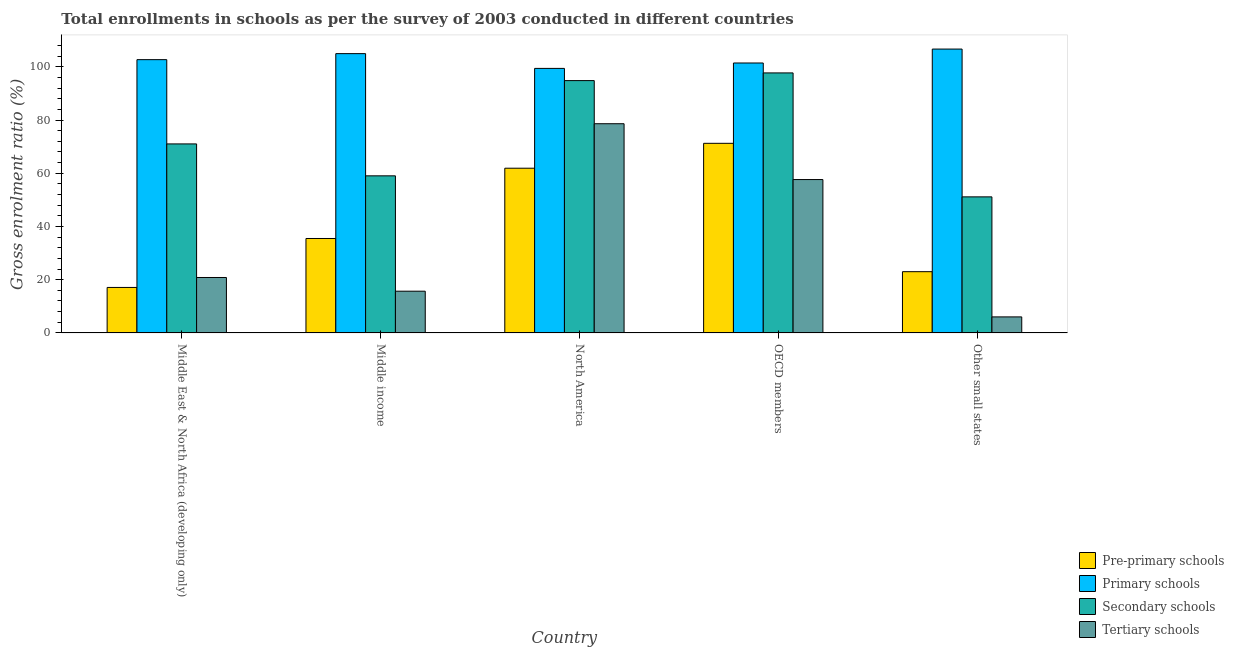How many groups of bars are there?
Ensure brevity in your answer.  5. Are the number of bars on each tick of the X-axis equal?
Offer a very short reply. Yes. What is the label of the 4th group of bars from the left?
Keep it short and to the point. OECD members. What is the gross enrolment ratio in primary schools in Middle East & North Africa (developing only)?
Offer a terse response. 102.67. Across all countries, what is the maximum gross enrolment ratio in tertiary schools?
Ensure brevity in your answer.  78.6. Across all countries, what is the minimum gross enrolment ratio in primary schools?
Provide a succinct answer. 99.39. In which country was the gross enrolment ratio in tertiary schools minimum?
Your answer should be very brief. Other small states. What is the total gross enrolment ratio in secondary schools in the graph?
Give a very brief answer. 373.66. What is the difference between the gross enrolment ratio in secondary schools in Middle East & North Africa (developing only) and that in OECD members?
Provide a succinct answer. -26.67. What is the difference between the gross enrolment ratio in secondary schools in Middle income and the gross enrolment ratio in tertiary schools in Middle East & North Africa (developing only)?
Make the answer very short. 38.19. What is the average gross enrolment ratio in secondary schools per country?
Provide a short and direct response. 74.73. What is the difference between the gross enrolment ratio in primary schools and gross enrolment ratio in secondary schools in North America?
Provide a short and direct response. 4.58. What is the ratio of the gross enrolment ratio in pre-primary schools in Middle income to that in OECD members?
Your response must be concise. 0.5. Is the difference between the gross enrolment ratio in secondary schools in North America and Other small states greater than the difference between the gross enrolment ratio in pre-primary schools in North America and Other small states?
Your answer should be compact. Yes. What is the difference between the highest and the second highest gross enrolment ratio in secondary schools?
Your answer should be very brief. 2.88. What is the difference between the highest and the lowest gross enrolment ratio in pre-primary schools?
Provide a succinct answer. 54.15. In how many countries, is the gross enrolment ratio in tertiary schools greater than the average gross enrolment ratio in tertiary schools taken over all countries?
Keep it short and to the point. 2. What does the 3rd bar from the left in OECD members represents?
Provide a succinct answer. Secondary schools. What does the 1st bar from the right in North America represents?
Offer a very short reply. Tertiary schools. Is it the case that in every country, the sum of the gross enrolment ratio in pre-primary schools and gross enrolment ratio in primary schools is greater than the gross enrolment ratio in secondary schools?
Your answer should be very brief. Yes. How many bars are there?
Your answer should be compact. 20. Are all the bars in the graph horizontal?
Your answer should be very brief. No. How many countries are there in the graph?
Make the answer very short. 5. What is the difference between two consecutive major ticks on the Y-axis?
Offer a terse response. 20. Does the graph contain grids?
Give a very brief answer. No. Where does the legend appear in the graph?
Provide a short and direct response. Bottom right. How are the legend labels stacked?
Your answer should be very brief. Vertical. What is the title of the graph?
Offer a very short reply. Total enrollments in schools as per the survey of 2003 conducted in different countries. Does "UNDP" appear as one of the legend labels in the graph?
Offer a very short reply. No. What is the label or title of the X-axis?
Provide a succinct answer. Country. What is the label or title of the Y-axis?
Keep it short and to the point. Gross enrolment ratio (%). What is the Gross enrolment ratio (%) of Pre-primary schools in Middle East & North Africa (developing only)?
Your answer should be very brief. 17.09. What is the Gross enrolment ratio (%) in Primary schools in Middle East & North Africa (developing only)?
Offer a very short reply. 102.67. What is the Gross enrolment ratio (%) in Secondary schools in Middle East & North Africa (developing only)?
Your response must be concise. 71.02. What is the Gross enrolment ratio (%) in Tertiary schools in Middle East & North Africa (developing only)?
Ensure brevity in your answer.  20.83. What is the Gross enrolment ratio (%) of Pre-primary schools in Middle income?
Offer a terse response. 35.49. What is the Gross enrolment ratio (%) of Primary schools in Middle income?
Offer a very short reply. 104.94. What is the Gross enrolment ratio (%) of Secondary schools in Middle income?
Give a very brief answer. 59.02. What is the Gross enrolment ratio (%) in Tertiary schools in Middle income?
Offer a terse response. 15.69. What is the Gross enrolment ratio (%) of Pre-primary schools in North America?
Provide a short and direct response. 61.89. What is the Gross enrolment ratio (%) of Primary schools in North America?
Give a very brief answer. 99.39. What is the Gross enrolment ratio (%) in Secondary schools in North America?
Make the answer very short. 94.81. What is the Gross enrolment ratio (%) of Tertiary schools in North America?
Ensure brevity in your answer.  78.6. What is the Gross enrolment ratio (%) of Pre-primary schools in OECD members?
Your response must be concise. 71.24. What is the Gross enrolment ratio (%) of Primary schools in OECD members?
Give a very brief answer. 101.42. What is the Gross enrolment ratio (%) in Secondary schools in OECD members?
Ensure brevity in your answer.  97.69. What is the Gross enrolment ratio (%) of Tertiary schools in OECD members?
Make the answer very short. 57.63. What is the Gross enrolment ratio (%) of Pre-primary schools in Other small states?
Provide a succinct answer. 23.01. What is the Gross enrolment ratio (%) in Primary schools in Other small states?
Offer a very short reply. 106.65. What is the Gross enrolment ratio (%) in Secondary schools in Other small states?
Your answer should be compact. 51.12. What is the Gross enrolment ratio (%) of Tertiary schools in Other small states?
Keep it short and to the point. 6.02. Across all countries, what is the maximum Gross enrolment ratio (%) of Pre-primary schools?
Your answer should be very brief. 71.24. Across all countries, what is the maximum Gross enrolment ratio (%) in Primary schools?
Make the answer very short. 106.65. Across all countries, what is the maximum Gross enrolment ratio (%) of Secondary schools?
Provide a succinct answer. 97.69. Across all countries, what is the maximum Gross enrolment ratio (%) of Tertiary schools?
Offer a terse response. 78.6. Across all countries, what is the minimum Gross enrolment ratio (%) of Pre-primary schools?
Offer a terse response. 17.09. Across all countries, what is the minimum Gross enrolment ratio (%) of Primary schools?
Keep it short and to the point. 99.39. Across all countries, what is the minimum Gross enrolment ratio (%) in Secondary schools?
Ensure brevity in your answer.  51.12. Across all countries, what is the minimum Gross enrolment ratio (%) in Tertiary schools?
Make the answer very short. 6.02. What is the total Gross enrolment ratio (%) in Pre-primary schools in the graph?
Your response must be concise. 208.72. What is the total Gross enrolment ratio (%) in Primary schools in the graph?
Your answer should be compact. 515.07. What is the total Gross enrolment ratio (%) in Secondary schools in the graph?
Your answer should be compact. 373.66. What is the total Gross enrolment ratio (%) in Tertiary schools in the graph?
Make the answer very short. 178.77. What is the difference between the Gross enrolment ratio (%) in Pre-primary schools in Middle East & North Africa (developing only) and that in Middle income?
Offer a very short reply. -18.4. What is the difference between the Gross enrolment ratio (%) of Primary schools in Middle East & North Africa (developing only) and that in Middle income?
Your answer should be compact. -2.26. What is the difference between the Gross enrolment ratio (%) of Secondary schools in Middle East & North Africa (developing only) and that in Middle income?
Your answer should be very brief. 11.99. What is the difference between the Gross enrolment ratio (%) of Tertiary schools in Middle East & North Africa (developing only) and that in Middle income?
Make the answer very short. 5.15. What is the difference between the Gross enrolment ratio (%) of Pre-primary schools in Middle East & North Africa (developing only) and that in North America?
Provide a short and direct response. -44.8. What is the difference between the Gross enrolment ratio (%) in Primary schools in Middle East & North Africa (developing only) and that in North America?
Offer a very short reply. 3.28. What is the difference between the Gross enrolment ratio (%) in Secondary schools in Middle East & North Africa (developing only) and that in North America?
Your response must be concise. -23.79. What is the difference between the Gross enrolment ratio (%) in Tertiary schools in Middle East & North Africa (developing only) and that in North America?
Offer a very short reply. -57.77. What is the difference between the Gross enrolment ratio (%) in Pre-primary schools in Middle East & North Africa (developing only) and that in OECD members?
Provide a short and direct response. -54.15. What is the difference between the Gross enrolment ratio (%) in Primary schools in Middle East & North Africa (developing only) and that in OECD members?
Provide a succinct answer. 1.25. What is the difference between the Gross enrolment ratio (%) in Secondary schools in Middle East & North Africa (developing only) and that in OECD members?
Make the answer very short. -26.67. What is the difference between the Gross enrolment ratio (%) in Tertiary schools in Middle East & North Africa (developing only) and that in OECD members?
Offer a very short reply. -36.8. What is the difference between the Gross enrolment ratio (%) of Pre-primary schools in Middle East & North Africa (developing only) and that in Other small states?
Give a very brief answer. -5.92. What is the difference between the Gross enrolment ratio (%) in Primary schools in Middle East & North Africa (developing only) and that in Other small states?
Give a very brief answer. -3.98. What is the difference between the Gross enrolment ratio (%) in Secondary schools in Middle East & North Africa (developing only) and that in Other small states?
Provide a succinct answer. 19.89. What is the difference between the Gross enrolment ratio (%) of Tertiary schools in Middle East & North Africa (developing only) and that in Other small states?
Provide a succinct answer. 14.81. What is the difference between the Gross enrolment ratio (%) in Pre-primary schools in Middle income and that in North America?
Provide a short and direct response. -26.4. What is the difference between the Gross enrolment ratio (%) in Primary schools in Middle income and that in North America?
Provide a succinct answer. 5.55. What is the difference between the Gross enrolment ratio (%) in Secondary schools in Middle income and that in North America?
Your response must be concise. -35.78. What is the difference between the Gross enrolment ratio (%) of Tertiary schools in Middle income and that in North America?
Keep it short and to the point. -62.91. What is the difference between the Gross enrolment ratio (%) in Pre-primary schools in Middle income and that in OECD members?
Provide a succinct answer. -35.76. What is the difference between the Gross enrolment ratio (%) in Primary schools in Middle income and that in OECD members?
Your response must be concise. 3.52. What is the difference between the Gross enrolment ratio (%) of Secondary schools in Middle income and that in OECD members?
Your answer should be very brief. -38.67. What is the difference between the Gross enrolment ratio (%) in Tertiary schools in Middle income and that in OECD members?
Offer a terse response. -41.94. What is the difference between the Gross enrolment ratio (%) in Pre-primary schools in Middle income and that in Other small states?
Offer a very short reply. 12.47. What is the difference between the Gross enrolment ratio (%) in Primary schools in Middle income and that in Other small states?
Your answer should be very brief. -1.71. What is the difference between the Gross enrolment ratio (%) of Secondary schools in Middle income and that in Other small states?
Ensure brevity in your answer.  7.9. What is the difference between the Gross enrolment ratio (%) of Tertiary schools in Middle income and that in Other small states?
Provide a short and direct response. 9.66. What is the difference between the Gross enrolment ratio (%) in Pre-primary schools in North America and that in OECD members?
Make the answer very short. -9.35. What is the difference between the Gross enrolment ratio (%) in Primary schools in North America and that in OECD members?
Ensure brevity in your answer.  -2.03. What is the difference between the Gross enrolment ratio (%) in Secondary schools in North America and that in OECD members?
Your answer should be compact. -2.88. What is the difference between the Gross enrolment ratio (%) of Tertiary schools in North America and that in OECD members?
Offer a very short reply. 20.97. What is the difference between the Gross enrolment ratio (%) in Pre-primary schools in North America and that in Other small states?
Provide a succinct answer. 38.88. What is the difference between the Gross enrolment ratio (%) of Primary schools in North America and that in Other small states?
Provide a short and direct response. -7.26. What is the difference between the Gross enrolment ratio (%) in Secondary schools in North America and that in Other small states?
Your response must be concise. 43.68. What is the difference between the Gross enrolment ratio (%) of Tertiary schools in North America and that in Other small states?
Offer a terse response. 72.58. What is the difference between the Gross enrolment ratio (%) of Pre-primary schools in OECD members and that in Other small states?
Your answer should be very brief. 48.23. What is the difference between the Gross enrolment ratio (%) in Primary schools in OECD members and that in Other small states?
Give a very brief answer. -5.23. What is the difference between the Gross enrolment ratio (%) in Secondary schools in OECD members and that in Other small states?
Offer a very short reply. 46.57. What is the difference between the Gross enrolment ratio (%) of Tertiary schools in OECD members and that in Other small states?
Your response must be concise. 51.6. What is the difference between the Gross enrolment ratio (%) in Pre-primary schools in Middle East & North Africa (developing only) and the Gross enrolment ratio (%) in Primary schools in Middle income?
Keep it short and to the point. -87.85. What is the difference between the Gross enrolment ratio (%) in Pre-primary schools in Middle East & North Africa (developing only) and the Gross enrolment ratio (%) in Secondary schools in Middle income?
Ensure brevity in your answer.  -41.93. What is the difference between the Gross enrolment ratio (%) in Pre-primary schools in Middle East & North Africa (developing only) and the Gross enrolment ratio (%) in Tertiary schools in Middle income?
Offer a terse response. 1.41. What is the difference between the Gross enrolment ratio (%) in Primary schools in Middle East & North Africa (developing only) and the Gross enrolment ratio (%) in Secondary schools in Middle income?
Provide a short and direct response. 43.65. What is the difference between the Gross enrolment ratio (%) of Primary schools in Middle East & North Africa (developing only) and the Gross enrolment ratio (%) of Tertiary schools in Middle income?
Your answer should be very brief. 86.99. What is the difference between the Gross enrolment ratio (%) in Secondary schools in Middle East & North Africa (developing only) and the Gross enrolment ratio (%) in Tertiary schools in Middle income?
Your answer should be compact. 55.33. What is the difference between the Gross enrolment ratio (%) of Pre-primary schools in Middle East & North Africa (developing only) and the Gross enrolment ratio (%) of Primary schools in North America?
Offer a terse response. -82.3. What is the difference between the Gross enrolment ratio (%) of Pre-primary schools in Middle East & North Africa (developing only) and the Gross enrolment ratio (%) of Secondary schools in North America?
Provide a short and direct response. -77.71. What is the difference between the Gross enrolment ratio (%) of Pre-primary schools in Middle East & North Africa (developing only) and the Gross enrolment ratio (%) of Tertiary schools in North America?
Provide a succinct answer. -61.51. What is the difference between the Gross enrolment ratio (%) in Primary schools in Middle East & North Africa (developing only) and the Gross enrolment ratio (%) in Secondary schools in North America?
Offer a very short reply. 7.87. What is the difference between the Gross enrolment ratio (%) in Primary schools in Middle East & North Africa (developing only) and the Gross enrolment ratio (%) in Tertiary schools in North America?
Make the answer very short. 24.07. What is the difference between the Gross enrolment ratio (%) of Secondary schools in Middle East & North Africa (developing only) and the Gross enrolment ratio (%) of Tertiary schools in North America?
Provide a succinct answer. -7.58. What is the difference between the Gross enrolment ratio (%) of Pre-primary schools in Middle East & North Africa (developing only) and the Gross enrolment ratio (%) of Primary schools in OECD members?
Your response must be concise. -84.33. What is the difference between the Gross enrolment ratio (%) in Pre-primary schools in Middle East & North Africa (developing only) and the Gross enrolment ratio (%) in Secondary schools in OECD members?
Your answer should be compact. -80.6. What is the difference between the Gross enrolment ratio (%) in Pre-primary schools in Middle East & North Africa (developing only) and the Gross enrolment ratio (%) in Tertiary schools in OECD members?
Provide a succinct answer. -40.54. What is the difference between the Gross enrolment ratio (%) of Primary schools in Middle East & North Africa (developing only) and the Gross enrolment ratio (%) of Secondary schools in OECD members?
Your response must be concise. 4.98. What is the difference between the Gross enrolment ratio (%) in Primary schools in Middle East & North Africa (developing only) and the Gross enrolment ratio (%) in Tertiary schools in OECD members?
Offer a terse response. 45.05. What is the difference between the Gross enrolment ratio (%) in Secondary schools in Middle East & North Africa (developing only) and the Gross enrolment ratio (%) in Tertiary schools in OECD members?
Your answer should be compact. 13.39. What is the difference between the Gross enrolment ratio (%) of Pre-primary schools in Middle East & North Africa (developing only) and the Gross enrolment ratio (%) of Primary schools in Other small states?
Your answer should be very brief. -89.56. What is the difference between the Gross enrolment ratio (%) in Pre-primary schools in Middle East & North Africa (developing only) and the Gross enrolment ratio (%) in Secondary schools in Other small states?
Provide a succinct answer. -34.03. What is the difference between the Gross enrolment ratio (%) of Pre-primary schools in Middle East & North Africa (developing only) and the Gross enrolment ratio (%) of Tertiary schools in Other small states?
Offer a very short reply. 11.07. What is the difference between the Gross enrolment ratio (%) of Primary schools in Middle East & North Africa (developing only) and the Gross enrolment ratio (%) of Secondary schools in Other small states?
Your answer should be compact. 51.55. What is the difference between the Gross enrolment ratio (%) of Primary schools in Middle East & North Africa (developing only) and the Gross enrolment ratio (%) of Tertiary schools in Other small states?
Give a very brief answer. 96.65. What is the difference between the Gross enrolment ratio (%) in Secondary schools in Middle East & North Africa (developing only) and the Gross enrolment ratio (%) in Tertiary schools in Other small states?
Your answer should be very brief. 64.99. What is the difference between the Gross enrolment ratio (%) in Pre-primary schools in Middle income and the Gross enrolment ratio (%) in Primary schools in North America?
Offer a very short reply. -63.9. What is the difference between the Gross enrolment ratio (%) of Pre-primary schools in Middle income and the Gross enrolment ratio (%) of Secondary schools in North America?
Your answer should be very brief. -59.32. What is the difference between the Gross enrolment ratio (%) of Pre-primary schools in Middle income and the Gross enrolment ratio (%) of Tertiary schools in North America?
Ensure brevity in your answer.  -43.11. What is the difference between the Gross enrolment ratio (%) of Primary schools in Middle income and the Gross enrolment ratio (%) of Secondary schools in North America?
Provide a succinct answer. 10.13. What is the difference between the Gross enrolment ratio (%) of Primary schools in Middle income and the Gross enrolment ratio (%) of Tertiary schools in North America?
Ensure brevity in your answer.  26.34. What is the difference between the Gross enrolment ratio (%) in Secondary schools in Middle income and the Gross enrolment ratio (%) in Tertiary schools in North America?
Provide a short and direct response. -19.58. What is the difference between the Gross enrolment ratio (%) of Pre-primary schools in Middle income and the Gross enrolment ratio (%) of Primary schools in OECD members?
Your answer should be compact. -65.94. What is the difference between the Gross enrolment ratio (%) of Pre-primary schools in Middle income and the Gross enrolment ratio (%) of Secondary schools in OECD members?
Your answer should be compact. -62.2. What is the difference between the Gross enrolment ratio (%) in Pre-primary schools in Middle income and the Gross enrolment ratio (%) in Tertiary schools in OECD members?
Ensure brevity in your answer.  -22.14. What is the difference between the Gross enrolment ratio (%) of Primary schools in Middle income and the Gross enrolment ratio (%) of Secondary schools in OECD members?
Your answer should be very brief. 7.25. What is the difference between the Gross enrolment ratio (%) of Primary schools in Middle income and the Gross enrolment ratio (%) of Tertiary schools in OECD members?
Provide a succinct answer. 47.31. What is the difference between the Gross enrolment ratio (%) of Secondary schools in Middle income and the Gross enrolment ratio (%) of Tertiary schools in OECD members?
Your answer should be compact. 1.39. What is the difference between the Gross enrolment ratio (%) in Pre-primary schools in Middle income and the Gross enrolment ratio (%) in Primary schools in Other small states?
Make the answer very short. -71.16. What is the difference between the Gross enrolment ratio (%) in Pre-primary schools in Middle income and the Gross enrolment ratio (%) in Secondary schools in Other small states?
Make the answer very short. -15.64. What is the difference between the Gross enrolment ratio (%) in Pre-primary schools in Middle income and the Gross enrolment ratio (%) in Tertiary schools in Other small states?
Make the answer very short. 29.46. What is the difference between the Gross enrolment ratio (%) of Primary schools in Middle income and the Gross enrolment ratio (%) of Secondary schools in Other small states?
Give a very brief answer. 53.81. What is the difference between the Gross enrolment ratio (%) of Primary schools in Middle income and the Gross enrolment ratio (%) of Tertiary schools in Other small states?
Give a very brief answer. 98.91. What is the difference between the Gross enrolment ratio (%) in Secondary schools in Middle income and the Gross enrolment ratio (%) in Tertiary schools in Other small states?
Ensure brevity in your answer.  53. What is the difference between the Gross enrolment ratio (%) of Pre-primary schools in North America and the Gross enrolment ratio (%) of Primary schools in OECD members?
Ensure brevity in your answer.  -39.53. What is the difference between the Gross enrolment ratio (%) of Pre-primary schools in North America and the Gross enrolment ratio (%) of Secondary schools in OECD members?
Ensure brevity in your answer.  -35.8. What is the difference between the Gross enrolment ratio (%) of Pre-primary schools in North America and the Gross enrolment ratio (%) of Tertiary schools in OECD members?
Offer a terse response. 4.26. What is the difference between the Gross enrolment ratio (%) in Primary schools in North America and the Gross enrolment ratio (%) in Secondary schools in OECD members?
Your response must be concise. 1.7. What is the difference between the Gross enrolment ratio (%) in Primary schools in North America and the Gross enrolment ratio (%) in Tertiary schools in OECD members?
Offer a very short reply. 41.76. What is the difference between the Gross enrolment ratio (%) in Secondary schools in North America and the Gross enrolment ratio (%) in Tertiary schools in OECD members?
Keep it short and to the point. 37.18. What is the difference between the Gross enrolment ratio (%) of Pre-primary schools in North America and the Gross enrolment ratio (%) of Primary schools in Other small states?
Keep it short and to the point. -44.76. What is the difference between the Gross enrolment ratio (%) in Pre-primary schools in North America and the Gross enrolment ratio (%) in Secondary schools in Other small states?
Offer a terse response. 10.77. What is the difference between the Gross enrolment ratio (%) in Pre-primary schools in North America and the Gross enrolment ratio (%) in Tertiary schools in Other small states?
Your response must be concise. 55.86. What is the difference between the Gross enrolment ratio (%) in Primary schools in North America and the Gross enrolment ratio (%) in Secondary schools in Other small states?
Keep it short and to the point. 48.27. What is the difference between the Gross enrolment ratio (%) of Primary schools in North America and the Gross enrolment ratio (%) of Tertiary schools in Other small states?
Provide a short and direct response. 93.36. What is the difference between the Gross enrolment ratio (%) in Secondary schools in North America and the Gross enrolment ratio (%) in Tertiary schools in Other small states?
Your response must be concise. 88.78. What is the difference between the Gross enrolment ratio (%) in Pre-primary schools in OECD members and the Gross enrolment ratio (%) in Primary schools in Other small states?
Provide a short and direct response. -35.41. What is the difference between the Gross enrolment ratio (%) in Pre-primary schools in OECD members and the Gross enrolment ratio (%) in Secondary schools in Other small states?
Provide a short and direct response. 20.12. What is the difference between the Gross enrolment ratio (%) in Pre-primary schools in OECD members and the Gross enrolment ratio (%) in Tertiary schools in Other small states?
Your answer should be very brief. 65.22. What is the difference between the Gross enrolment ratio (%) of Primary schools in OECD members and the Gross enrolment ratio (%) of Secondary schools in Other small states?
Provide a short and direct response. 50.3. What is the difference between the Gross enrolment ratio (%) of Primary schools in OECD members and the Gross enrolment ratio (%) of Tertiary schools in Other small states?
Your answer should be compact. 95.4. What is the difference between the Gross enrolment ratio (%) in Secondary schools in OECD members and the Gross enrolment ratio (%) in Tertiary schools in Other small states?
Offer a terse response. 91.67. What is the average Gross enrolment ratio (%) in Pre-primary schools per country?
Make the answer very short. 41.74. What is the average Gross enrolment ratio (%) in Primary schools per country?
Keep it short and to the point. 103.01. What is the average Gross enrolment ratio (%) of Secondary schools per country?
Your answer should be very brief. 74.73. What is the average Gross enrolment ratio (%) of Tertiary schools per country?
Provide a succinct answer. 35.75. What is the difference between the Gross enrolment ratio (%) in Pre-primary schools and Gross enrolment ratio (%) in Primary schools in Middle East & North Africa (developing only)?
Your answer should be compact. -85.58. What is the difference between the Gross enrolment ratio (%) in Pre-primary schools and Gross enrolment ratio (%) in Secondary schools in Middle East & North Africa (developing only)?
Offer a terse response. -53.93. What is the difference between the Gross enrolment ratio (%) of Pre-primary schools and Gross enrolment ratio (%) of Tertiary schools in Middle East & North Africa (developing only)?
Provide a succinct answer. -3.74. What is the difference between the Gross enrolment ratio (%) of Primary schools and Gross enrolment ratio (%) of Secondary schools in Middle East & North Africa (developing only)?
Keep it short and to the point. 31.66. What is the difference between the Gross enrolment ratio (%) in Primary schools and Gross enrolment ratio (%) in Tertiary schools in Middle East & North Africa (developing only)?
Your response must be concise. 81.84. What is the difference between the Gross enrolment ratio (%) of Secondary schools and Gross enrolment ratio (%) of Tertiary schools in Middle East & North Africa (developing only)?
Your answer should be very brief. 50.19. What is the difference between the Gross enrolment ratio (%) in Pre-primary schools and Gross enrolment ratio (%) in Primary schools in Middle income?
Ensure brevity in your answer.  -69.45. What is the difference between the Gross enrolment ratio (%) of Pre-primary schools and Gross enrolment ratio (%) of Secondary schools in Middle income?
Offer a very short reply. -23.54. What is the difference between the Gross enrolment ratio (%) of Pre-primary schools and Gross enrolment ratio (%) of Tertiary schools in Middle income?
Your answer should be compact. 19.8. What is the difference between the Gross enrolment ratio (%) of Primary schools and Gross enrolment ratio (%) of Secondary schools in Middle income?
Provide a short and direct response. 45.91. What is the difference between the Gross enrolment ratio (%) of Primary schools and Gross enrolment ratio (%) of Tertiary schools in Middle income?
Provide a short and direct response. 89.25. What is the difference between the Gross enrolment ratio (%) of Secondary schools and Gross enrolment ratio (%) of Tertiary schools in Middle income?
Offer a very short reply. 43.34. What is the difference between the Gross enrolment ratio (%) of Pre-primary schools and Gross enrolment ratio (%) of Primary schools in North America?
Your answer should be compact. -37.5. What is the difference between the Gross enrolment ratio (%) of Pre-primary schools and Gross enrolment ratio (%) of Secondary schools in North America?
Your answer should be compact. -32.92. What is the difference between the Gross enrolment ratio (%) of Pre-primary schools and Gross enrolment ratio (%) of Tertiary schools in North America?
Ensure brevity in your answer.  -16.71. What is the difference between the Gross enrolment ratio (%) of Primary schools and Gross enrolment ratio (%) of Secondary schools in North America?
Your response must be concise. 4.58. What is the difference between the Gross enrolment ratio (%) of Primary schools and Gross enrolment ratio (%) of Tertiary schools in North America?
Ensure brevity in your answer.  20.79. What is the difference between the Gross enrolment ratio (%) in Secondary schools and Gross enrolment ratio (%) in Tertiary schools in North America?
Give a very brief answer. 16.21. What is the difference between the Gross enrolment ratio (%) in Pre-primary schools and Gross enrolment ratio (%) in Primary schools in OECD members?
Provide a succinct answer. -30.18. What is the difference between the Gross enrolment ratio (%) of Pre-primary schools and Gross enrolment ratio (%) of Secondary schools in OECD members?
Ensure brevity in your answer.  -26.45. What is the difference between the Gross enrolment ratio (%) in Pre-primary schools and Gross enrolment ratio (%) in Tertiary schools in OECD members?
Your response must be concise. 13.61. What is the difference between the Gross enrolment ratio (%) in Primary schools and Gross enrolment ratio (%) in Secondary schools in OECD members?
Your response must be concise. 3.73. What is the difference between the Gross enrolment ratio (%) of Primary schools and Gross enrolment ratio (%) of Tertiary schools in OECD members?
Give a very brief answer. 43.79. What is the difference between the Gross enrolment ratio (%) of Secondary schools and Gross enrolment ratio (%) of Tertiary schools in OECD members?
Offer a terse response. 40.06. What is the difference between the Gross enrolment ratio (%) of Pre-primary schools and Gross enrolment ratio (%) of Primary schools in Other small states?
Keep it short and to the point. -83.64. What is the difference between the Gross enrolment ratio (%) in Pre-primary schools and Gross enrolment ratio (%) in Secondary schools in Other small states?
Provide a short and direct response. -28.11. What is the difference between the Gross enrolment ratio (%) in Pre-primary schools and Gross enrolment ratio (%) in Tertiary schools in Other small states?
Ensure brevity in your answer.  16.99. What is the difference between the Gross enrolment ratio (%) in Primary schools and Gross enrolment ratio (%) in Secondary schools in Other small states?
Offer a very short reply. 55.53. What is the difference between the Gross enrolment ratio (%) in Primary schools and Gross enrolment ratio (%) in Tertiary schools in Other small states?
Offer a very short reply. 100.63. What is the difference between the Gross enrolment ratio (%) of Secondary schools and Gross enrolment ratio (%) of Tertiary schools in Other small states?
Provide a short and direct response. 45.1. What is the ratio of the Gross enrolment ratio (%) in Pre-primary schools in Middle East & North Africa (developing only) to that in Middle income?
Provide a succinct answer. 0.48. What is the ratio of the Gross enrolment ratio (%) of Primary schools in Middle East & North Africa (developing only) to that in Middle income?
Your answer should be very brief. 0.98. What is the ratio of the Gross enrolment ratio (%) of Secondary schools in Middle East & North Africa (developing only) to that in Middle income?
Offer a very short reply. 1.2. What is the ratio of the Gross enrolment ratio (%) of Tertiary schools in Middle East & North Africa (developing only) to that in Middle income?
Provide a short and direct response. 1.33. What is the ratio of the Gross enrolment ratio (%) in Pre-primary schools in Middle East & North Africa (developing only) to that in North America?
Keep it short and to the point. 0.28. What is the ratio of the Gross enrolment ratio (%) of Primary schools in Middle East & North Africa (developing only) to that in North America?
Your response must be concise. 1.03. What is the ratio of the Gross enrolment ratio (%) in Secondary schools in Middle East & North Africa (developing only) to that in North America?
Your response must be concise. 0.75. What is the ratio of the Gross enrolment ratio (%) in Tertiary schools in Middle East & North Africa (developing only) to that in North America?
Ensure brevity in your answer.  0.27. What is the ratio of the Gross enrolment ratio (%) of Pre-primary schools in Middle East & North Africa (developing only) to that in OECD members?
Provide a succinct answer. 0.24. What is the ratio of the Gross enrolment ratio (%) of Primary schools in Middle East & North Africa (developing only) to that in OECD members?
Offer a terse response. 1.01. What is the ratio of the Gross enrolment ratio (%) of Secondary schools in Middle East & North Africa (developing only) to that in OECD members?
Provide a short and direct response. 0.73. What is the ratio of the Gross enrolment ratio (%) of Tertiary schools in Middle East & North Africa (developing only) to that in OECD members?
Your response must be concise. 0.36. What is the ratio of the Gross enrolment ratio (%) in Pre-primary schools in Middle East & North Africa (developing only) to that in Other small states?
Your answer should be compact. 0.74. What is the ratio of the Gross enrolment ratio (%) of Primary schools in Middle East & North Africa (developing only) to that in Other small states?
Your answer should be compact. 0.96. What is the ratio of the Gross enrolment ratio (%) in Secondary schools in Middle East & North Africa (developing only) to that in Other small states?
Ensure brevity in your answer.  1.39. What is the ratio of the Gross enrolment ratio (%) in Tertiary schools in Middle East & North Africa (developing only) to that in Other small states?
Offer a terse response. 3.46. What is the ratio of the Gross enrolment ratio (%) in Pre-primary schools in Middle income to that in North America?
Give a very brief answer. 0.57. What is the ratio of the Gross enrolment ratio (%) in Primary schools in Middle income to that in North America?
Provide a succinct answer. 1.06. What is the ratio of the Gross enrolment ratio (%) in Secondary schools in Middle income to that in North America?
Provide a short and direct response. 0.62. What is the ratio of the Gross enrolment ratio (%) in Tertiary schools in Middle income to that in North America?
Keep it short and to the point. 0.2. What is the ratio of the Gross enrolment ratio (%) of Pre-primary schools in Middle income to that in OECD members?
Provide a short and direct response. 0.5. What is the ratio of the Gross enrolment ratio (%) in Primary schools in Middle income to that in OECD members?
Provide a succinct answer. 1.03. What is the ratio of the Gross enrolment ratio (%) of Secondary schools in Middle income to that in OECD members?
Your answer should be very brief. 0.6. What is the ratio of the Gross enrolment ratio (%) in Tertiary schools in Middle income to that in OECD members?
Your answer should be compact. 0.27. What is the ratio of the Gross enrolment ratio (%) of Pre-primary schools in Middle income to that in Other small states?
Offer a very short reply. 1.54. What is the ratio of the Gross enrolment ratio (%) in Primary schools in Middle income to that in Other small states?
Offer a very short reply. 0.98. What is the ratio of the Gross enrolment ratio (%) in Secondary schools in Middle income to that in Other small states?
Provide a short and direct response. 1.15. What is the ratio of the Gross enrolment ratio (%) of Tertiary schools in Middle income to that in Other small states?
Provide a succinct answer. 2.6. What is the ratio of the Gross enrolment ratio (%) of Pre-primary schools in North America to that in OECD members?
Make the answer very short. 0.87. What is the ratio of the Gross enrolment ratio (%) in Primary schools in North America to that in OECD members?
Make the answer very short. 0.98. What is the ratio of the Gross enrolment ratio (%) in Secondary schools in North America to that in OECD members?
Your answer should be very brief. 0.97. What is the ratio of the Gross enrolment ratio (%) of Tertiary schools in North America to that in OECD members?
Ensure brevity in your answer.  1.36. What is the ratio of the Gross enrolment ratio (%) in Pre-primary schools in North America to that in Other small states?
Your answer should be compact. 2.69. What is the ratio of the Gross enrolment ratio (%) of Primary schools in North America to that in Other small states?
Give a very brief answer. 0.93. What is the ratio of the Gross enrolment ratio (%) of Secondary schools in North America to that in Other small states?
Offer a very short reply. 1.85. What is the ratio of the Gross enrolment ratio (%) in Tertiary schools in North America to that in Other small states?
Your response must be concise. 13.05. What is the ratio of the Gross enrolment ratio (%) in Pre-primary schools in OECD members to that in Other small states?
Provide a succinct answer. 3.1. What is the ratio of the Gross enrolment ratio (%) in Primary schools in OECD members to that in Other small states?
Provide a short and direct response. 0.95. What is the ratio of the Gross enrolment ratio (%) of Secondary schools in OECD members to that in Other small states?
Your answer should be very brief. 1.91. What is the ratio of the Gross enrolment ratio (%) in Tertiary schools in OECD members to that in Other small states?
Make the answer very short. 9.57. What is the difference between the highest and the second highest Gross enrolment ratio (%) in Pre-primary schools?
Ensure brevity in your answer.  9.35. What is the difference between the highest and the second highest Gross enrolment ratio (%) of Primary schools?
Your answer should be very brief. 1.71. What is the difference between the highest and the second highest Gross enrolment ratio (%) in Secondary schools?
Offer a terse response. 2.88. What is the difference between the highest and the second highest Gross enrolment ratio (%) in Tertiary schools?
Your response must be concise. 20.97. What is the difference between the highest and the lowest Gross enrolment ratio (%) of Pre-primary schools?
Your answer should be compact. 54.15. What is the difference between the highest and the lowest Gross enrolment ratio (%) of Primary schools?
Ensure brevity in your answer.  7.26. What is the difference between the highest and the lowest Gross enrolment ratio (%) in Secondary schools?
Make the answer very short. 46.57. What is the difference between the highest and the lowest Gross enrolment ratio (%) in Tertiary schools?
Keep it short and to the point. 72.58. 